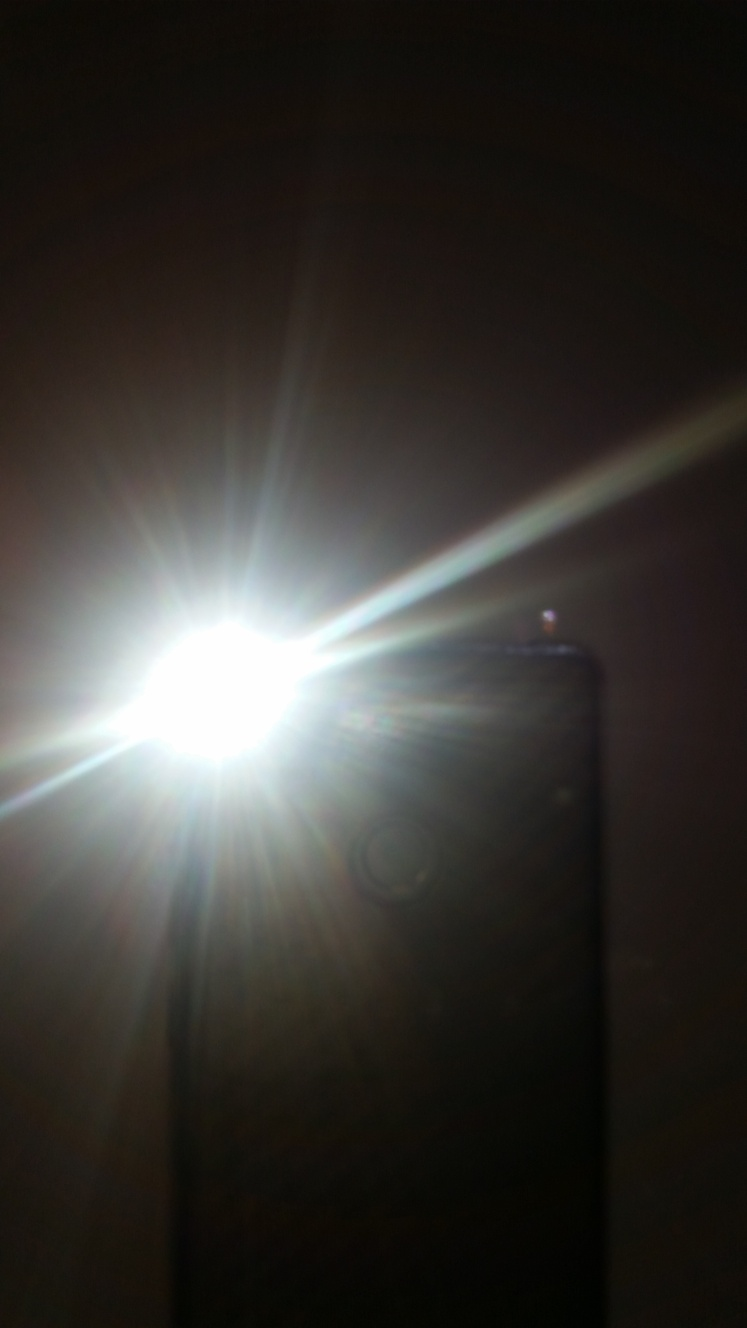Can this effect be used artistically, and if so, how? Absolutely! Overexposure can be used artistically to convey a sense of ethereal quality, highlight a specific area of a picture, or create a deliberate 'washed out' look. Artists often use it for stylistic reasons to evoke certain emotions or to draw attention to the subject through contrast with the surrounding elements. 